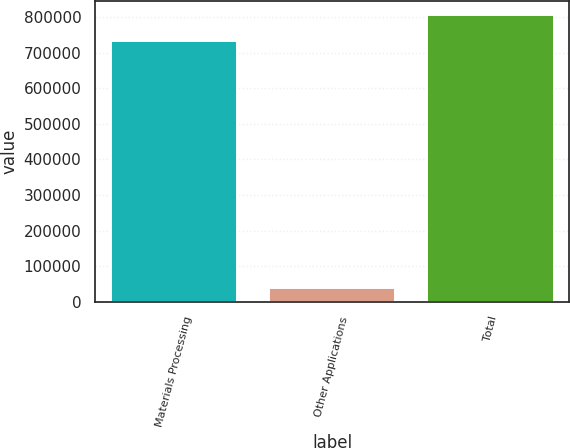<chart> <loc_0><loc_0><loc_500><loc_500><bar_chart><fcel>Materials Processing<fcel>Other Applications<fcel>Total<nl><fcel>731274<fcel>38558<fcel>804401<nl></chart> 